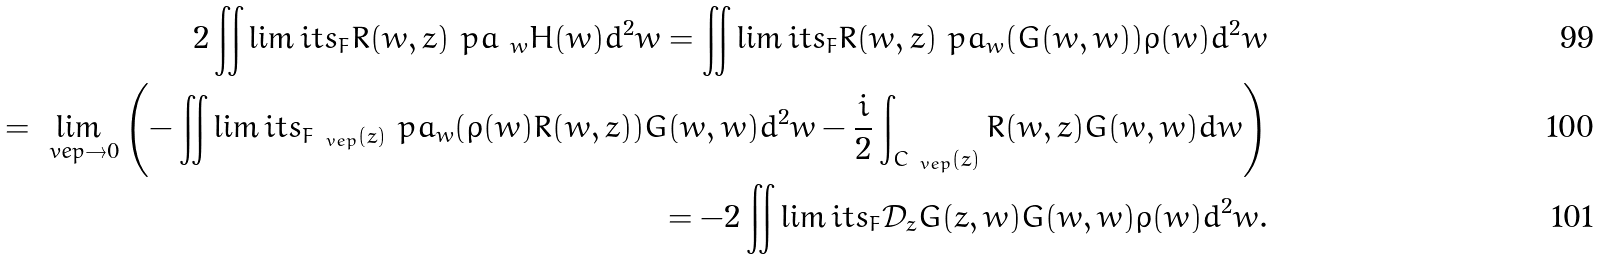Convert formula to latex. <formula><loc_0><loc_0><loc_500><loc_500>2 \iint \lim i t s _ { F } R ( w , z ) \ p a _ { \ w } H ( w ) d ^ { 2 } w = \iint \lim i t s _ { F } R ( w , z ) \ p a _ { w } ( G ( w , w ) ) \rho ( w ) d ^ { 2 } w \\ = \lim _ { \ v e p \rightarrow 0 } \left ( - \iint \lim i t s _ { F _ { \ v e p } ( z ) } \ p a _ { w } ( \rho ( w ) R ( w , z ) ) G ( w , w ) d ^ { 2 } w - \frac { i } { 2 } \int _ { C _ { \ v e p } ( z ) } R ( w , z ) G ( w , w ) d \bar { w } \right ) \\ = - 2 \iint \lim i t s _ { F } \mathcal { D } _ { z } G ( z , w ) G ( w , w ) \rho ( w ) d ^ { 2 } w .</formula> 